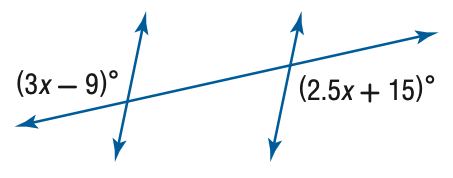Question: Find x.
Choices:
A. 6
B. 12
C. 24
D. 48
Answer with the letter. Answer: D 